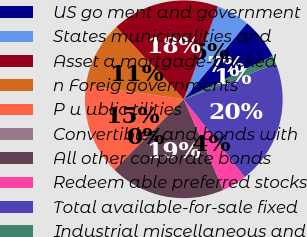Convert chart. <chart><loc_0><loc_0><loc_500><loc_500><pie_chart><fcel>US go ment and government<fcel>States municipalities and<fcel>Asset a mortgage-backed<fcel>n Foreig governments<fcel>P u ublic tilities<fcel>Convertibles and bonds with<fcel>All other corporate bonds<fcel>Redeem able preferred stocks<fcel>Total available-for-sale fixed<fcel>Industrial miscellaneous and<nl><fcel>6.76%<fcel>5.41%<fcel>17.57%<fcel>10.81%<fcel>14.86%<fcel>0.0%<fcel>18.92%<fcel>4.06%<fcel>20.27%<fcel>1.35%<nl></chart> 